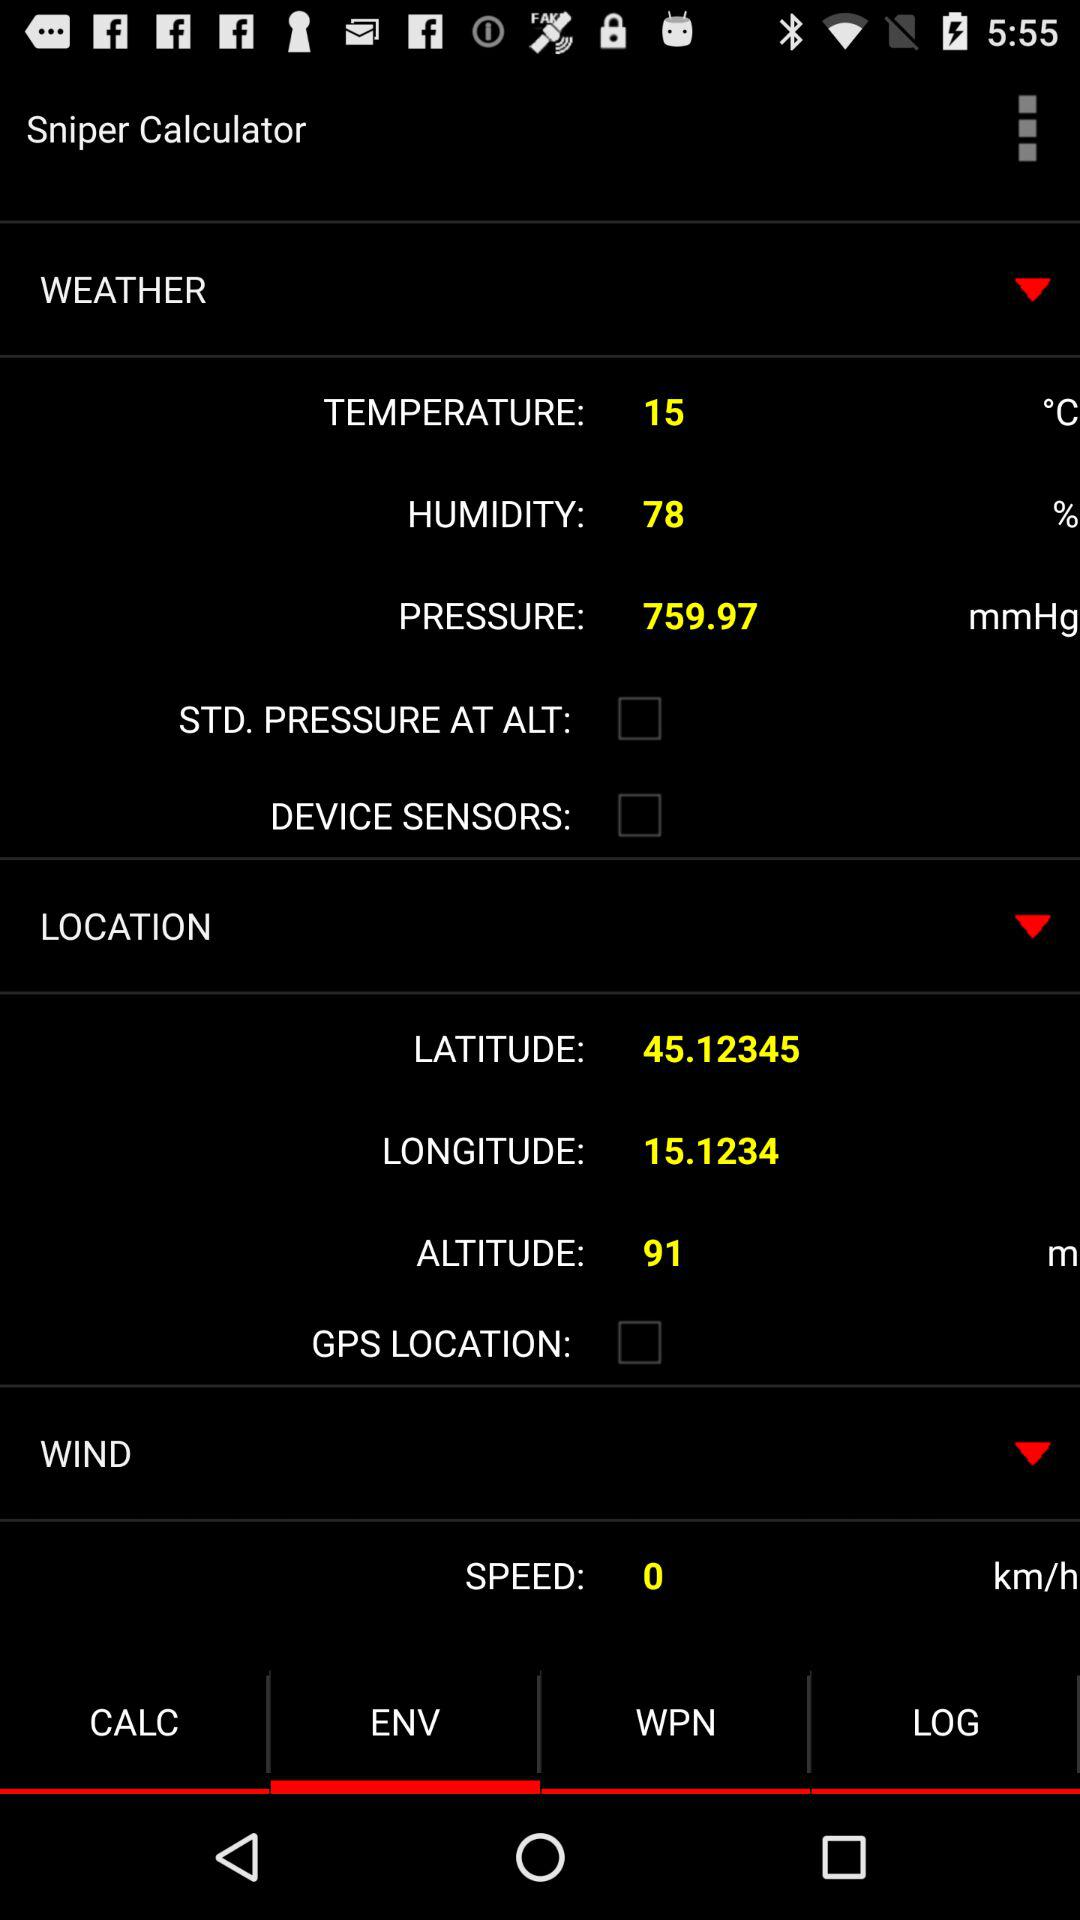Which tab is selected? The selected tab is "ENV". 